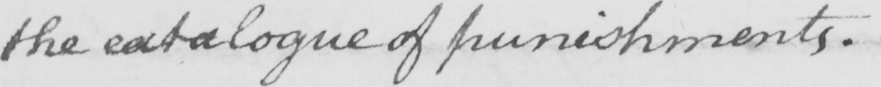Can you read and transcribe this handwriting? the catalogue of punishments . 